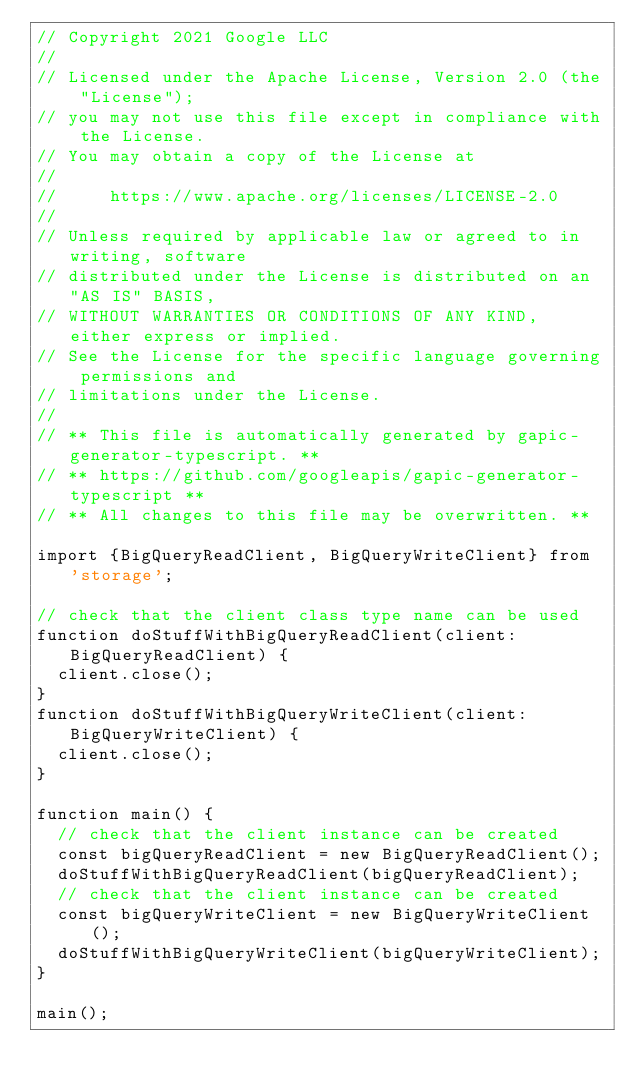Convert code to text. <code><loc_0><loc_0><loc_500><loc_500><_TypeScript_>// Copyright 2021 Google LLC
//
// Licensed under the Apache License, Version 2.0 (the "License");
// you may not use this file except in compliance with the License.
// You may obtain a copy of the License at
//
//     https://www.apache.org/licenses/LICENSE-2.0
//
// Unless required by applicable law or agreed to in writing, software
// distributed under the License is distributed on an "AS IS" BASIS,
// WITHOUT WARRANTIES OR CONDITIONS OF ANY KIND, either express or implied.
// See the License for the specific language governing permissions and
// limitations under the License.
//
// ** This file is automatically generated by gapic-generator-typescript. **
// ** https://github.com/googleapis/gapic-generator-typescript **
// ** All changes to this file may be overwritten. **

import {BigQueryReadClient, BigQueryWriteClient} from 'storage';

// check that the client class type name can be used
function doStuffWithBigQueryReadClient(client: BigQueryReadClient) {
  client.close();
}
function doStuffWithBigQueryWriteClient(client: BigQueryWriteClient) {
  client.close();
}

function main() {
  // check that the client instance can be created
  const bigQueryReadClient = new BigQueryReadClient();
  doStuffWithBigQueryReadClient(bigQueryReadClient);
  // check that the client instance can be created
  const bigQueryWriteClient = new BigQueryWriteClient();
  doStuffWithBigQueryWriteClient(bigQueryWriteClient);
}

main();
</code> 